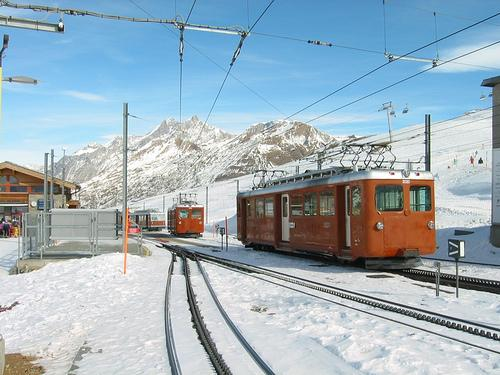Do the train tracks appear to be covered with a certain substance? If so, what is it? Yes, the train tracks appear to be covered with snow. Identify the predominant weather condition depicted in the image. There is white snow on the ground and some snow-covered mountains in the distance. State the type of landscape that can be found in the background of the image. A snow-covered mountain range and hills with a clear blue sky and clouds. In your own words, describe the most significant scene displayed in the image. A large brown train on a track surrounded by snow, with mountains in the background and a clear blue sky with clouds. Describe the surroundings of the train in the image and mention if there is anything noteworthy about the environment. The train is surrounded by snow-covered ground and train tracks, with a mountain range in the background, a blue sky with clouds, and a train station building nearby. Name one unique feature of the train depicted in the image that is not typically found on all trains. An electric wire contact stand connecting the train to the grid. What mode of transportation is most prominently featured in the image? A large brown electric train on a track surrounded by snow. Choose a task and provide a sample product advertisement text that might be inspired by this image. Introducing the Alpine Express, the perfect way to travel through the snowy winter wonderland. Experience stunning mountain views and cosy cabins, all from the comfort of our eco-friendly electric trains. Book your ticket now and rediscover the magic of winter. Provide a brief description of the most notable architectural structure in the image. A train station building with a slanted roof, clear windows, and situated near the train tracks amidst the snowy landscape. Choose a task and provide a sample question-answer pair based on the details of the image. Answer: B. Snow 